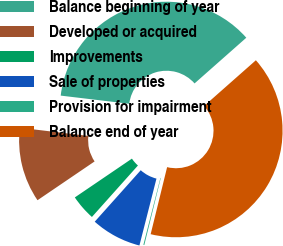<chart> <loc_0><loc_0><loc_500><loc_500><pie_chart><fcel>Balance beginning of year<fcel>Developed or acquired<fcel>Improvements<fcel>Sale of properties<fcel>Provision for impairment<fcel>Balance end of year<nl><fcel>36.6%<fcel>11.39%<fcel>3.89%<fcel>7.64%<fcel>0.14%<fcel>40.35%<nl></chart> 